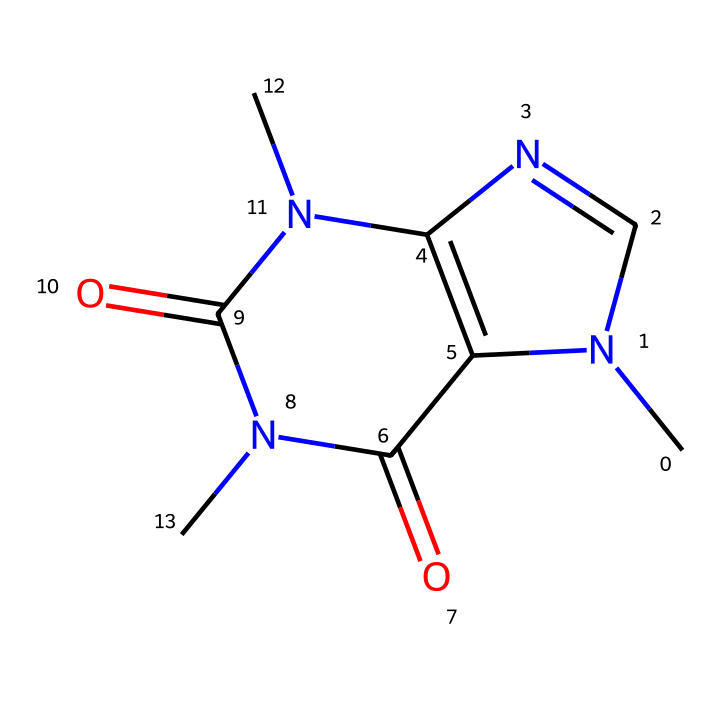What is the primary functional group present in caffeine? Caffeine contains both amine and carbonyl functional groups (the nitrogen atoms represent the amine and the carbonyls are indicated by the C=O bonds). The presence of these groups is characteristic of many alkaloids.
Answer: amine, carbonyl How many nitrogen atoms are in the caffeine structure? By examining the SMILES representation, we can identify three nitrogen (N) atoms present in the structure. Each nitrogen atom contributes to the alkaloid nature of caffeine.
Answer: three What type of structure does caffeine primarily exhibit? Caffeine exhibits a fused bicyclic structure, as indicated by the connected carbocycles formed by the combination of the nitrogen and carbon atoms in the rings. This unique bicyclic arrangement is typical for many alkaloids.
Answer: bicyclic How many total carbon atoms does caffeine contain? In the SMILES representation, there are eight carbon (C) atoms throughout the structure providing a base for the rest of the functional groups within caffeine.
Answer: eight What is the molecular formula for caffeine? By analyzing the number of each type of atom from the SMILES string (8 Carbon, 10 Hydrogen, 4 Nitrogen, 2 Oxygen), we can derive the molecular formula for caffeine.
Answer: C8H10N4O2 What characteristic property of caffeine is attributed to its nitrogen atoms? The presence of nitrogen atoms in caffeine contributes to its psychoactive effects, often stimulating the central nervous system due to their role in altering neurotransmitter activity.
Answer: psychoactive effects How does caffeine's structure impact its solubility in water? The polar nitrogen and oxygen atoms in the structure enhance the solubility of caffeine in water as they can interact favorably with water molecules, making it more soluble than non-polar compounds.
Answer: enhances solubility 